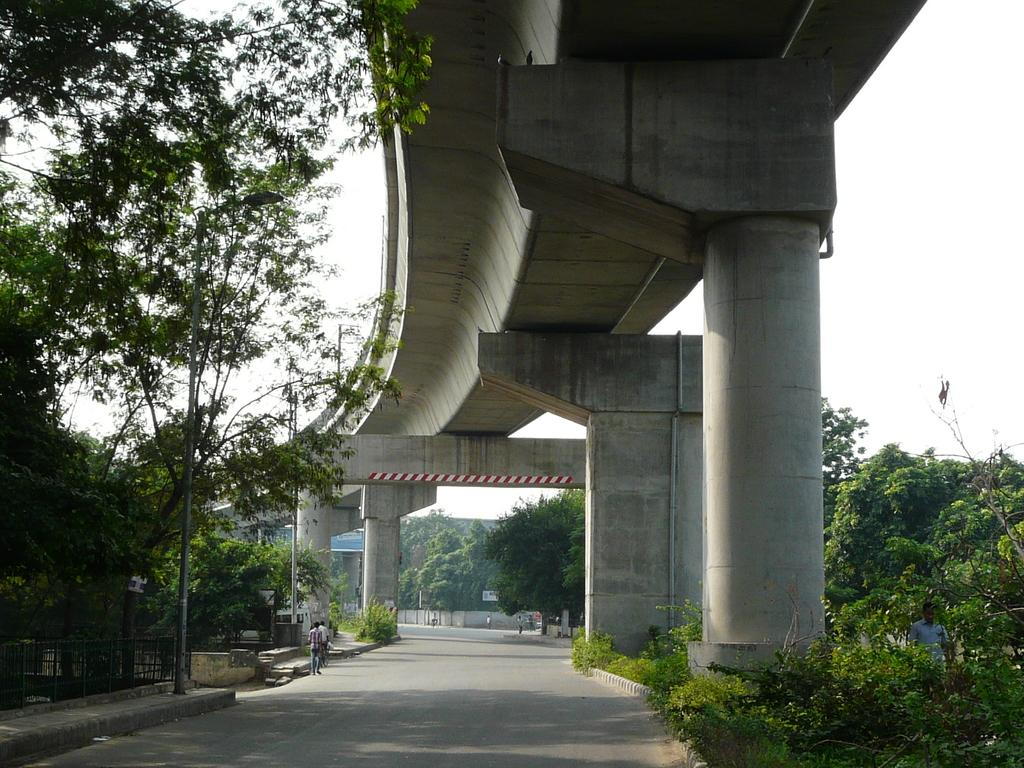What type of structure is present in the image? There is a flyover in the image. What are the pillars supporting in the image? The pillars are supporting the flyover in the image. What type of vegetation can be seen in the image? There are trees in the image. What other structures are present in the image? There are poles and a fence in the image. Are there any people in the image? Yes, there are people in the image. What type of signage is present in the image? There are boards with text in the image. What else can be seen in the background of the image? There is a wall in the image. What is visible in the sky in the image? The sky is visible in the image. What type of bear can be seen walking on the fence in the image? There is no bear present in the image, and therefore no such activity can be observed. 